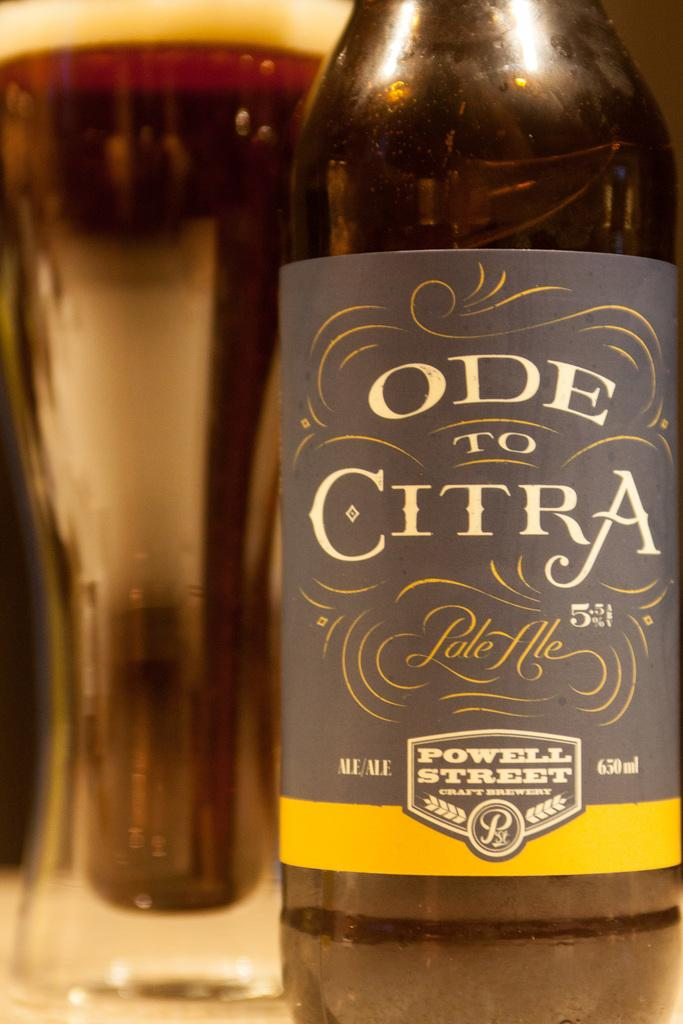<image>
Summarize the visual content of the image. A bottle is labeled Ode to Citra and is a pale ale. 